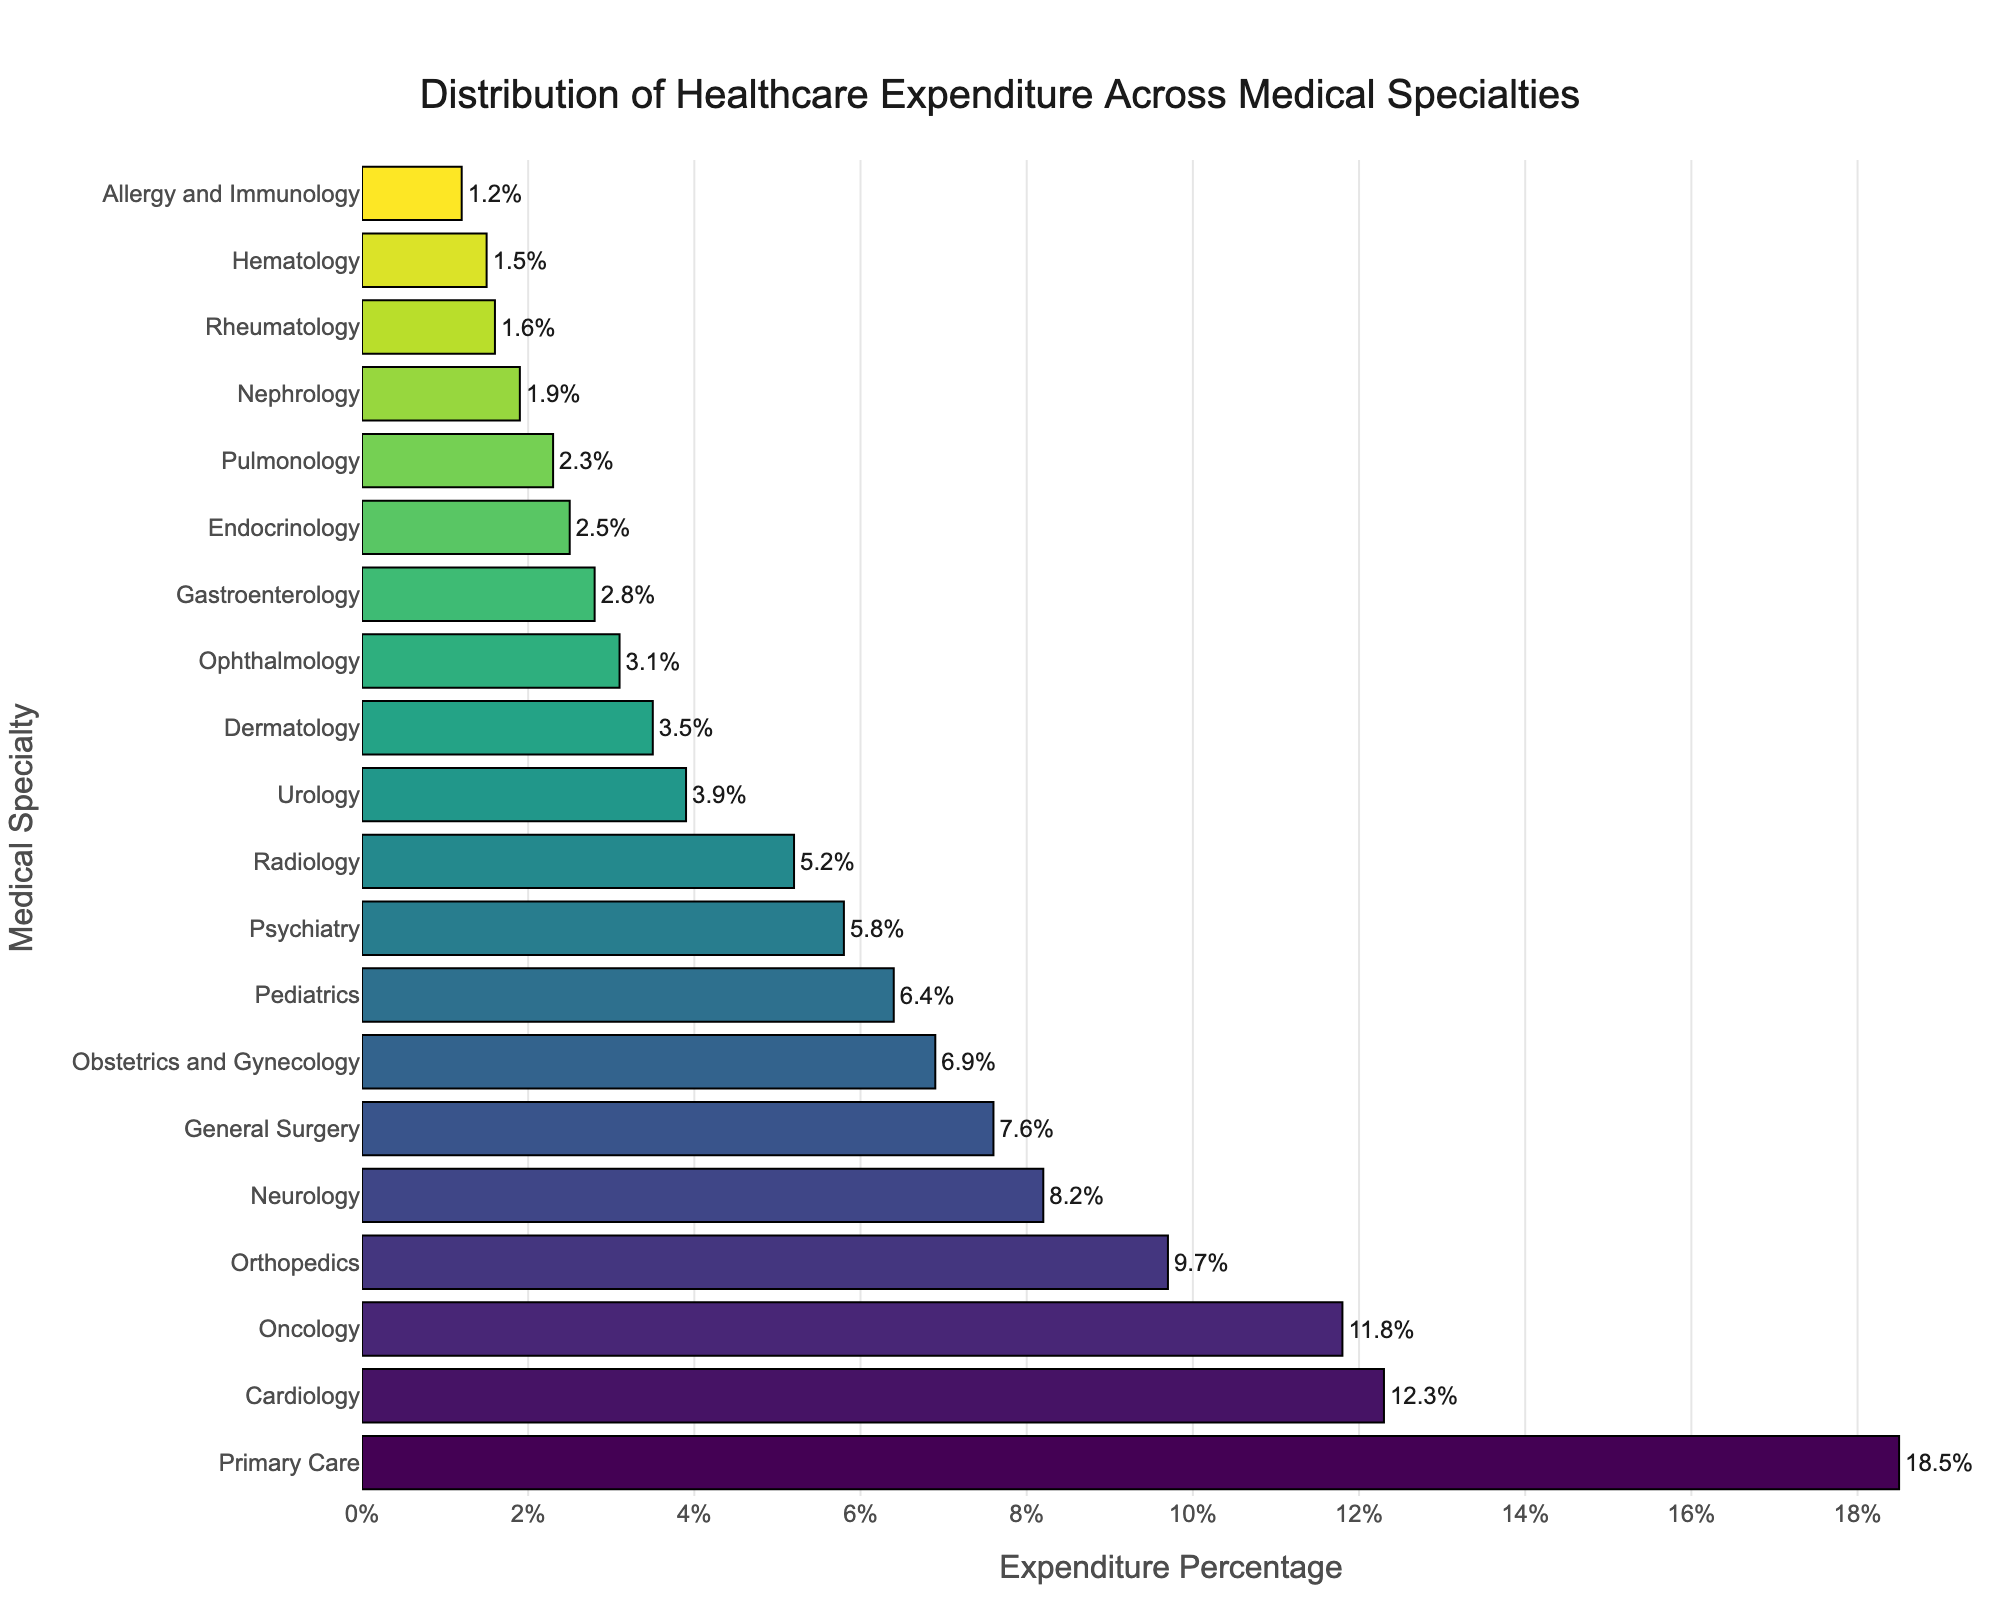Which medical specialty has the highest expenditure percentage? The bar corresponding to "Primary Care" is the longest, indicating it has the highest expenditure percentage of 18.5%.
Answer: Primary Care What is the combined expenditure percentage for Cardiology and Oncology? Cardiology has an expenditure percentage of 12.3%, and Oncology has 11.8%. Adding them together: 12.3 + 11.8 = 24.1
Answer: 24.1 How much more is spent on Neurology compared to Gastroenterology? Neurology has an expenditure percentage of 8.2%, and Gastroenterology has 2.8%. Subtracting them: 8.2 - 2.8 = 5.4
Answer: 5.4 Which specialties have an expenditure percentage greater than Psychiatry? Psychiatry has an expenditure percentage of 5.8%. The specialties with a higher expenditure are Primary Care (18.5%), Cardiology (12.3%), Oncology (11.8%), Orthopedics (9.7%), Neurology (8.2%), General Surgery (7.6%), Obstetrics and Gynecology (6.9%), and Pediatrics (6.4%).
Answer: Primary Care, Cardiology, Oncology, Orthopedics, Neurology, General Surgery, Obstetrics and Gynecology, Pediatrics What is the expenditure percentage for the specialty with the least expenditure? The shortest bar corresponds to Allergy and Immunology, indicating the lowest expenditure percentage of 1.2%.
Answer: 1.2 By how much does the expenditure on Primary Care exceed that on Secondary Care specialties like Cardiology and Oncology combined? Primary Care has an expenditure percentage of 18.5%. The combined expenditure for Cardiology (12.3%) and Oncology (11.8%) is 24.1%. Subtracting these gives: 24.1 - 18.5 = 5.6
Answer: 5.6 What is the average expenditure percentage for Primary Care, Cardiology, and Oncology? The expenditure percentages are Primary Care (18.5%), Cardiology (12.3%), and Oncology (11.8%). Adding these and dividing by 3: (18.5 + 12.3 + 11.8)/3 = 42.6/3 = 14.2
Answer: 14.2 Which specialties have an expenditure percentage below the average expenditure for all specialties? The total expenditure percentages for all specialties are 100%. There are 20 specialties in total, so the average is 100/20 = 5%. The specialties below this average are Radiology (5.2), Urology (3.9), Dermatology (3.5), Ophthalmology (3.1), Gastroenterology (2.8), Endocrinology (2.5), Pulmonology (2.3), Nephrology (1.9), Rheumatology (1.6), Hematology (1.5), and Allergy and Immunology (1.2).
Answer: Radiology, Urology, Dermatology, Ophthalmology, Gastroenterology, Endocrinology, Pulmonology, Nephrology, Rheumatology, Hematology, Allergy and Immunology How does the expenditure on General Surgery compare visually to Obstetrics and Gynecology? Both General Surgery and Obstetrics and Gynecology have slightly different but comparable bar lengths. General Surgery has an expenditure of 7.6%, while Obstetrics and Gynecology has 6.9%, indicating General Surgery has a slightly higher expenditure.
Answer: General Surgery has a slightly higher expenditure What is the total expenditure percentage for the specialties starting with "P"? The specialties are Primary Care (18.5%), Pediatrics (6.4%), Psychiatry (5.8%), and Pulmonology (2.3%). Adding them: 18.5 + 6.4 + 5.8 + 2.3 = 33
Answer: 33 